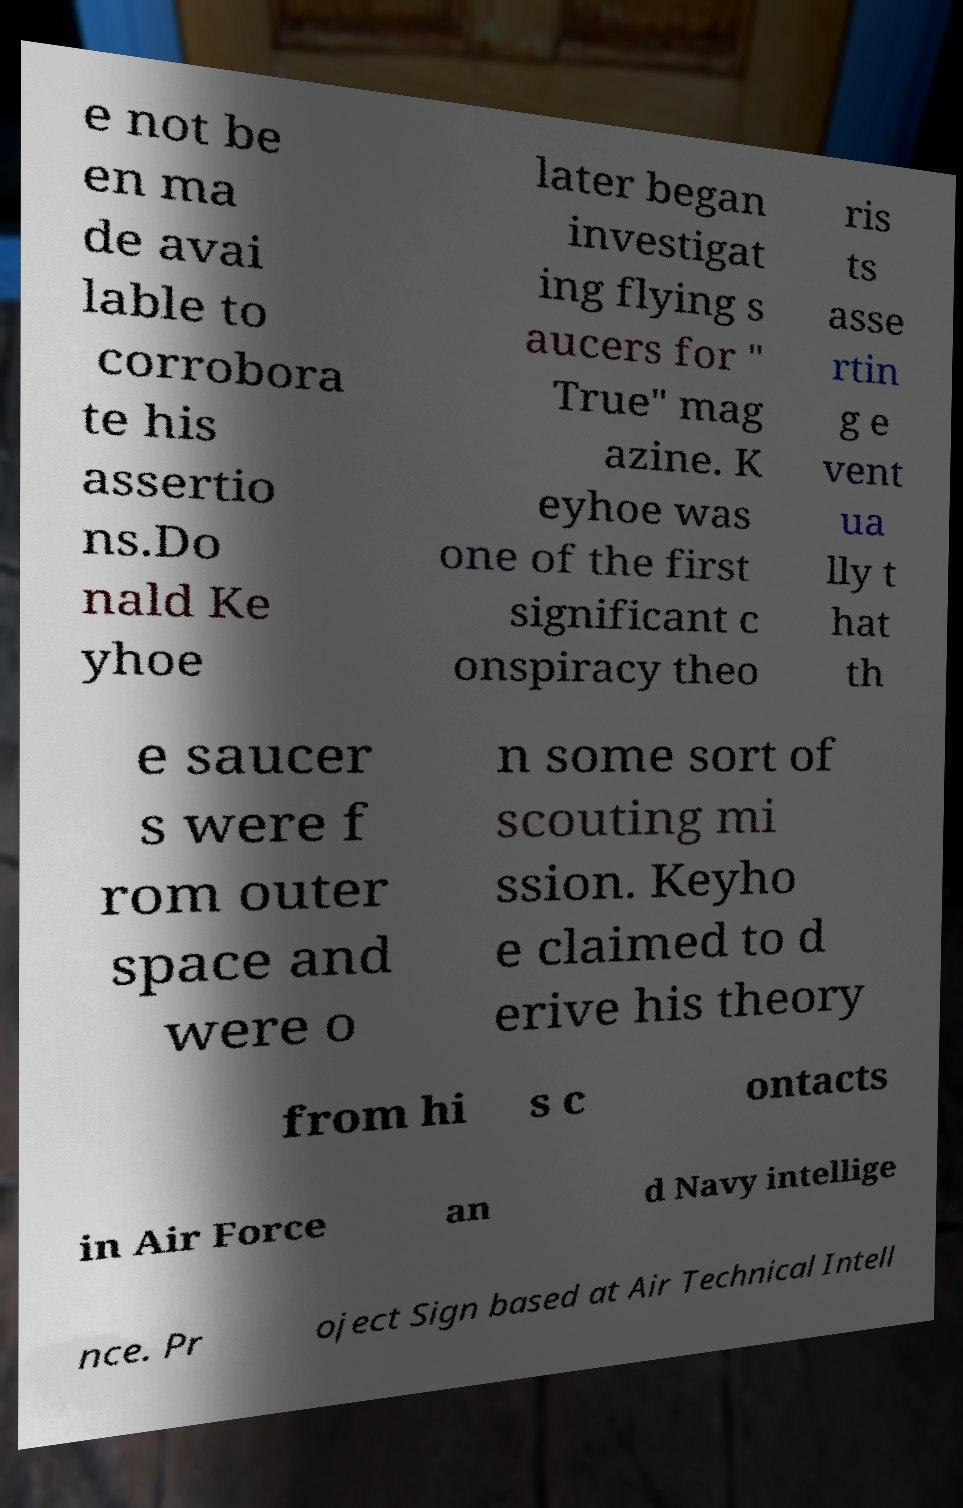Please identify and transcribe the text found in this image. e not be en ma de avai lable to corrobora te his assertio ns.Do nald Ke yhoe later began investigat ing flying s aucers for " True" mag azine. K eyhoe was one of the first significant c onspiracy theo ris ts asse rtin g e vent ua lly t hat th e saucer s were f rom outer space and were o n some sort of scouting mi ssion. Keyho e claimed to d erive his theory from hi s c ontacts in Air Force an d Navy intellige nce. Pr oject Sign based at Air Technical Intell 